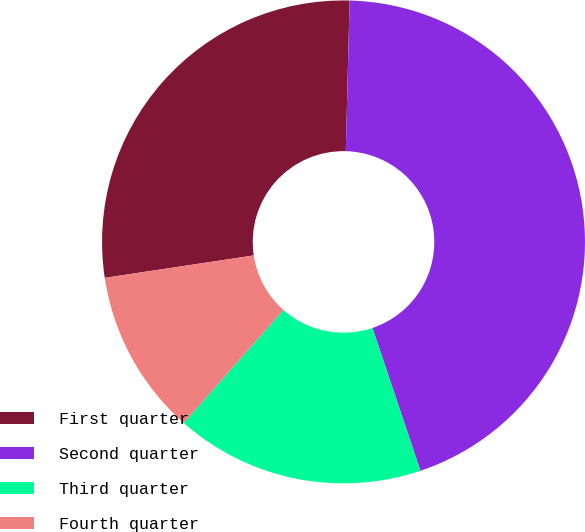Convert chart to OTSL. <chart><loc_0><loc_0><loc_500><loc_500><pie_chart><fcel>First quarter<fcel>Second quarter<fcel>Third quarter<fcel>Fourth quarter<nl><fcel>27.78%<fcel>44.44%<fcel>16.67%<fcel>11.11%<nl></chart> 